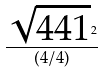Convert formula to latex. <formula><loc_0><loc_0><loc_500><loc_500>\frac { \sqrt { 4 4 1 } ^ { 2 } } { ( 4 / 4 ) }</formula> 